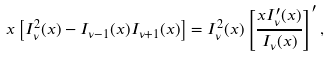<formula> <loc_0><loc_0><loc_500><loc_500>x \left [ I _ { \nu } ^ { 2 } ( x ) - I _ { \nu - 1 } ( x ) I _ { \nu + 1 } ( x ) \right ] = I _ { \nu } ^ { 2 } ( x ) \left [ \frac { x I _ { \nu } ^ { \prime } ( x ) } { I _ { \nu } ( x ) } \right ] ^ { \prime } ,</formula> 